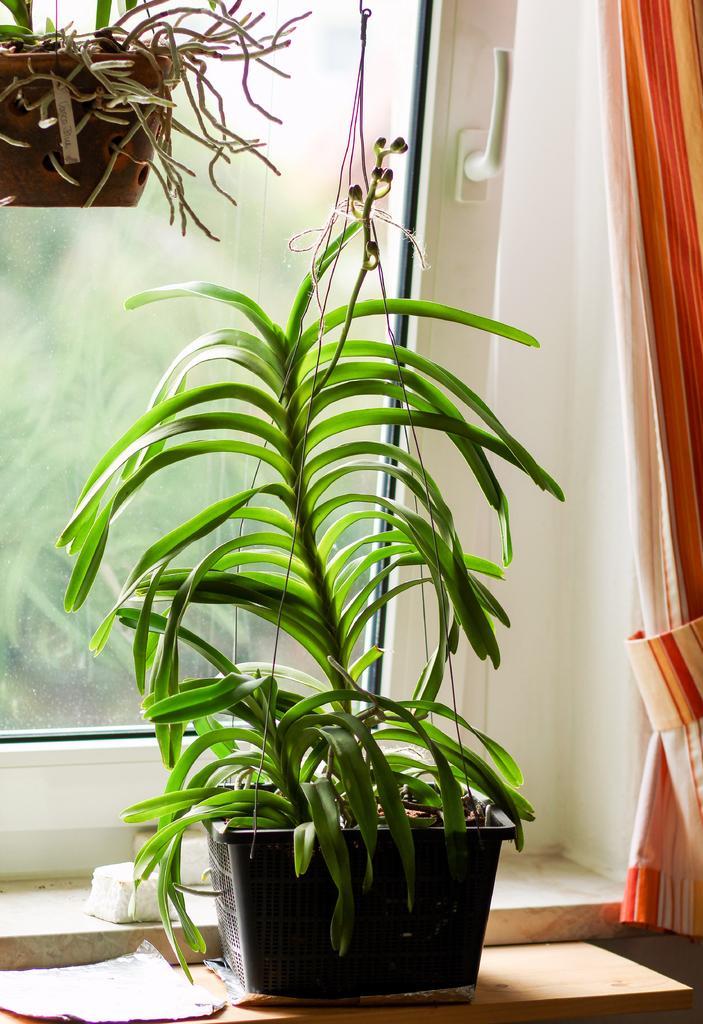How would you summarize this image in a sentence or two? In this picture we can see few plants, beside to the plants we can find a window and curtain. 